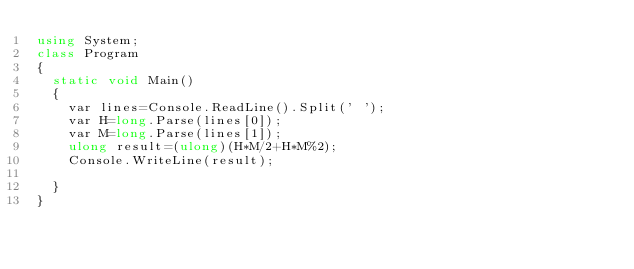Convert code to text. <code><loc_0><loc_0><loc_500><loc_500><_C#_>using System;
class Program
{
  static void Main()
  {
    var lines=Console.ReadLine().Split(' ');
    var H=long.Parse(lines[0]);
    var M=long.Parse(lines[1]);
    ulong result=(ulong)(H*M/2+H*M%2);
    Console.WriteLine(result);
    
  }
}</code> 